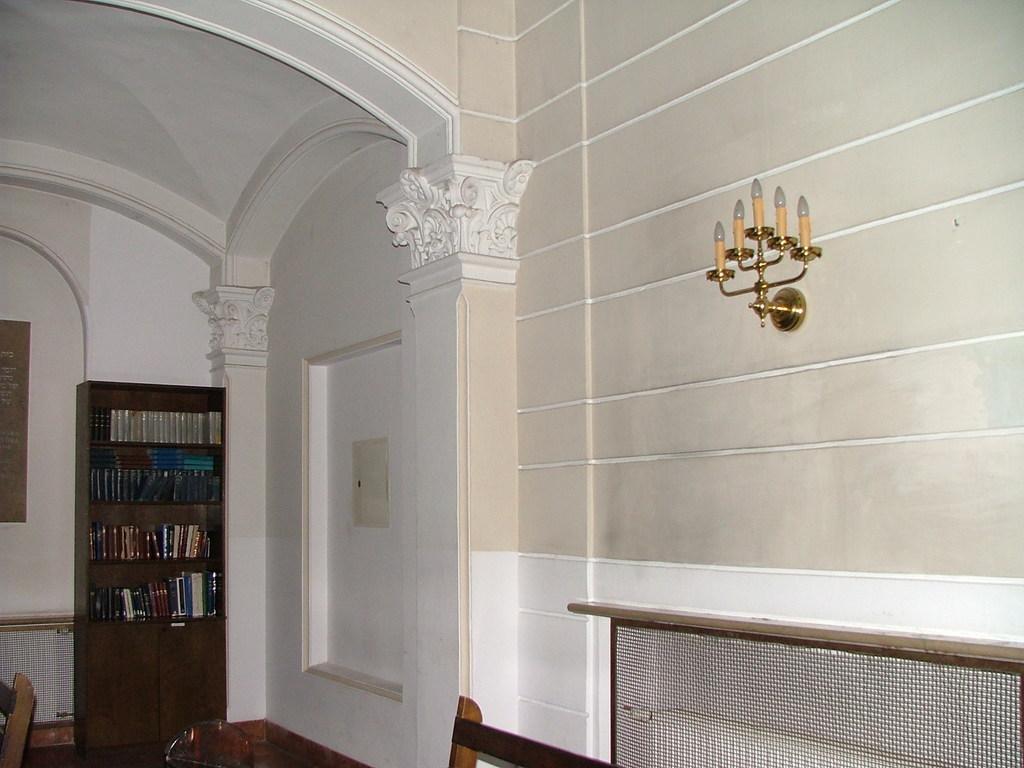Can you describe this image briefly? In the image on the left side there is a wall. And also there is a cupboard with books. There are pillars with arches and designs. On the right side of the image there is a wall with stand and lights. In the bottom right corner of the image there is a mesh and also there is a wooden object. 